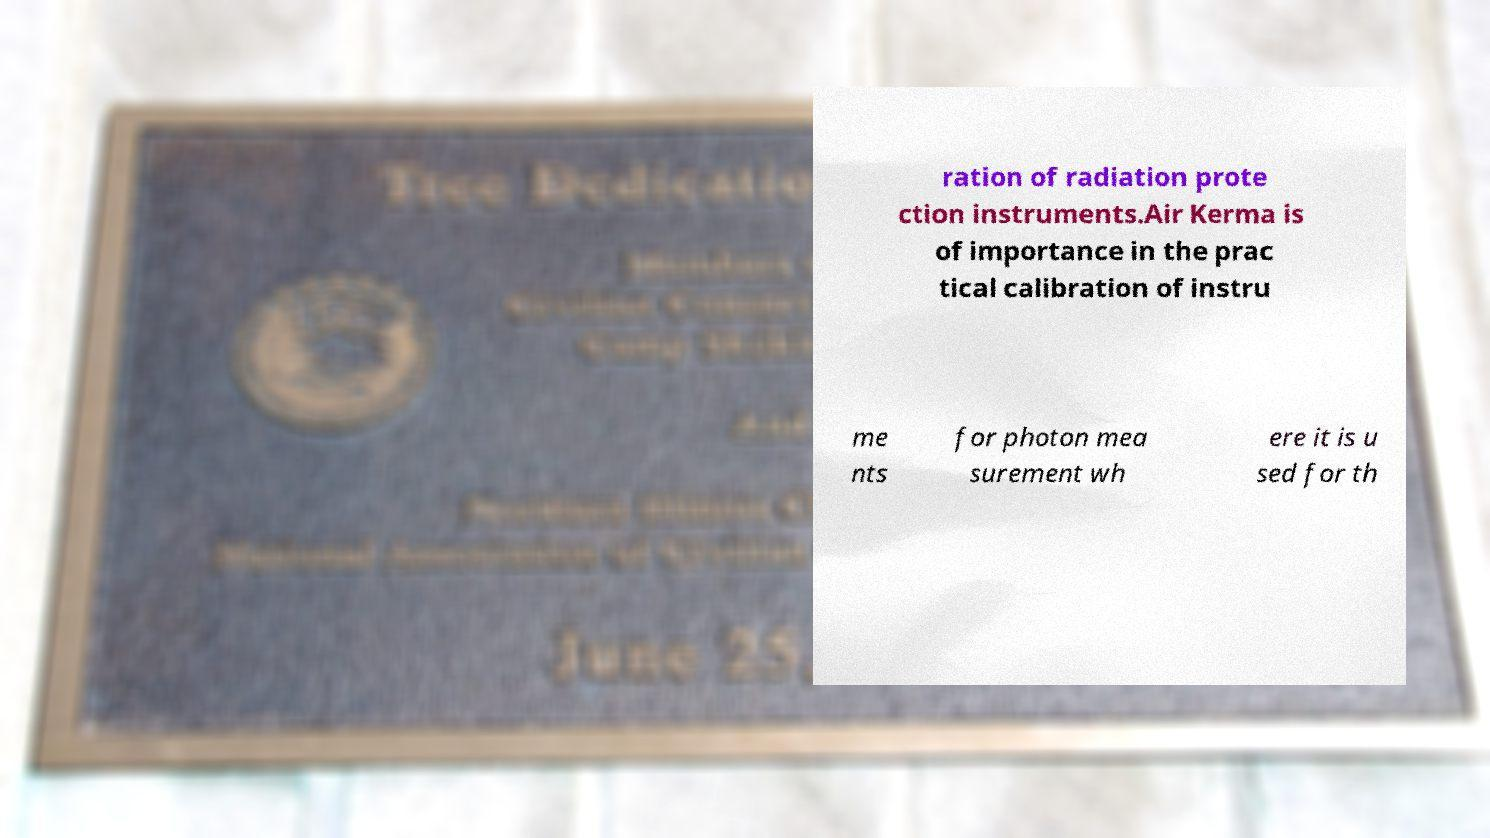Could you assist in decoding the text presented in this image and type it out clearly? ration of radiation prote ction instruments.Air Kerma is of importance in the prac tical calibration of instru me nts for photon mea surement wh ere it is u sed for th 